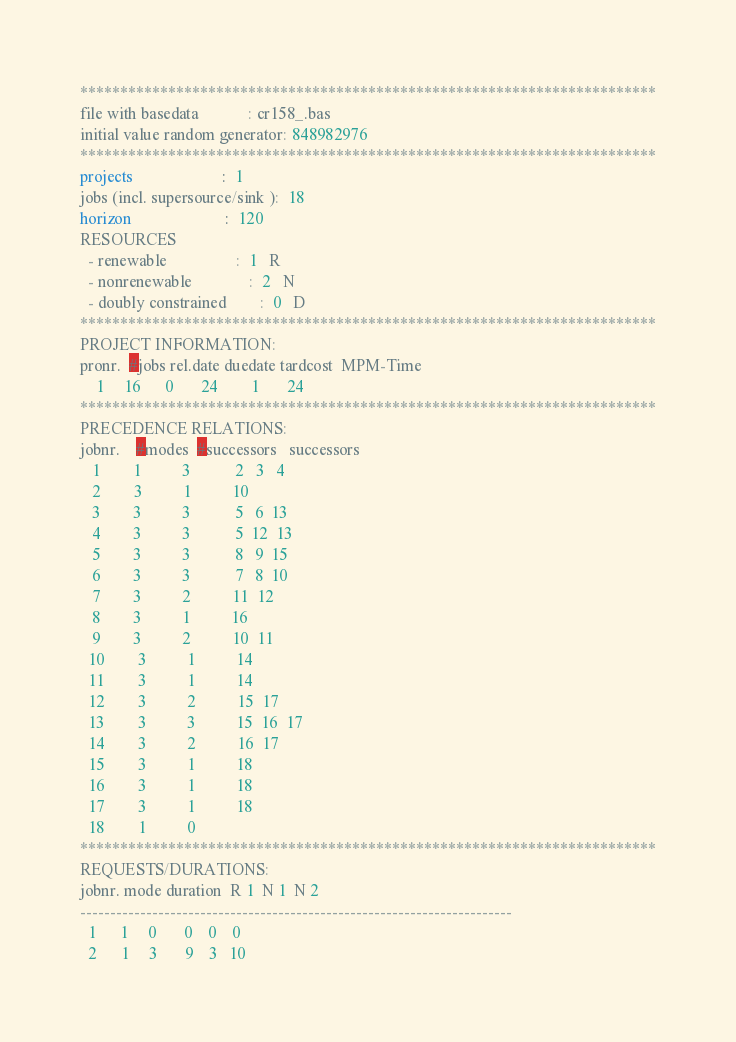Convert code to text. <code><loc_0><loc_0><loc_500><loc_500><_ObjectiveC_>************************************************************************
file with basedata            : cr158_.bas
initial value random generator: 848982976
************************************************************************
projects                      :  1
jobs (incl. supersource/sink ):  18
horizon                       :  120
RESOURCES
  - renewable                 :  1   R
  - nonrenewable              :  2   N
  - doubly constrained        :  0   D
************************************************************************
PROJECT INFORMATION:
pronr.  #jobs rel.date duedate tardcost  MPM-Time
    1     16      0       24        1       24
************************************************************************
PRECEDENCE RELATIONS:
jobnr.    #modes  #successors   successors
   1        1          3           2   3   4
   2        3          1          10
   3        3          3           5   6  13
   4        3          3           5  12  13
   5        3          3           8   9  15
   6        3          3           7   8  10
   7        3          2          11  12
   8        3          1          16
   9        3          2          10  11
  10        3          1          14
  11        3          1          14
  12        3          2          15  17
  13        3          3          15  16  17
  14        3          2          16  17
  15        3          1          18
  16        3          1          18
  17        3          1          18
  18        1          0        
************************************************************************
REQUESTS/DURATIONS:
jobnr. mode duration  R 1  N 1  N 2
------------------------------------------------------------------------
  1      1     0       0    0    0
  2      1     3       9    3   10</code> 